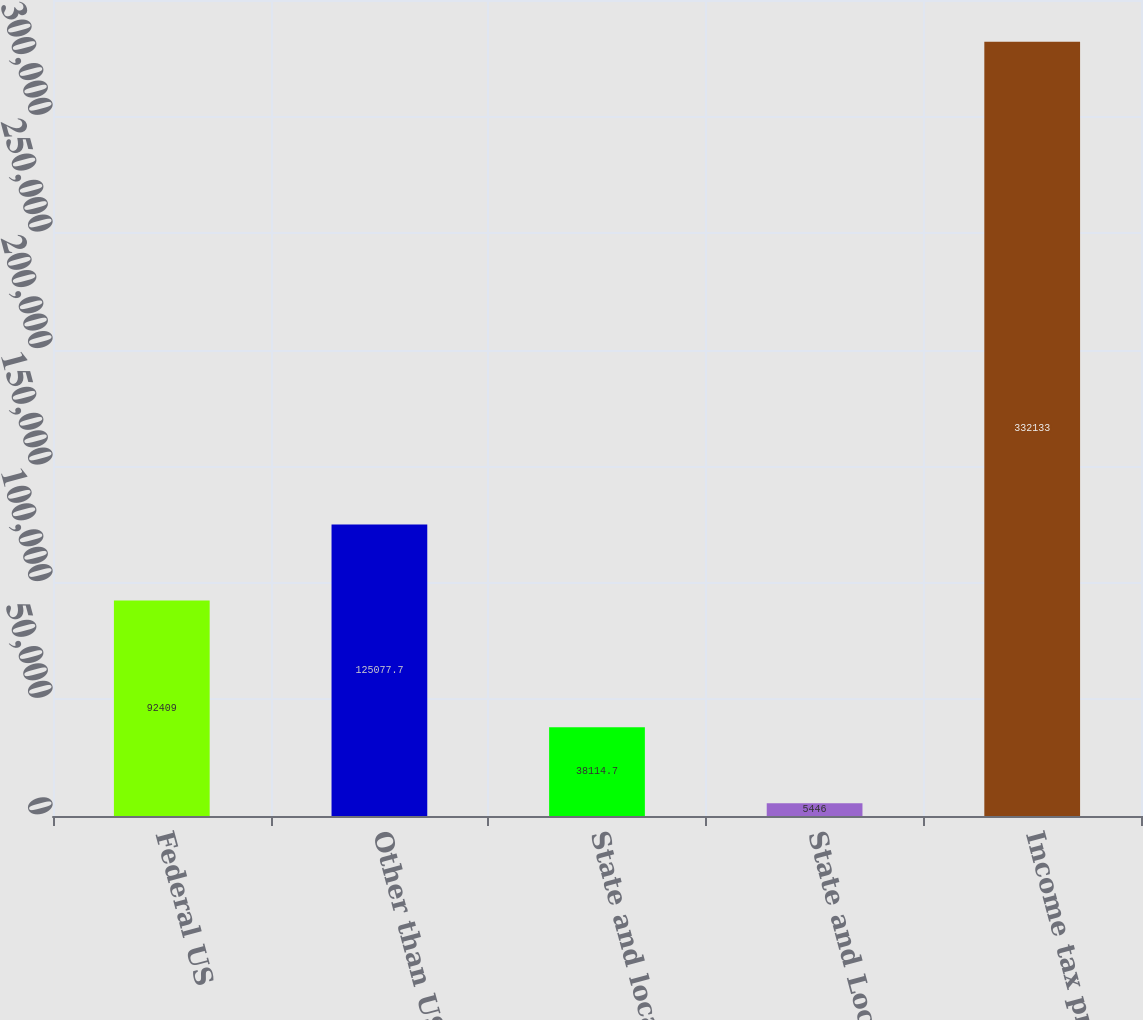Convert chart to OTSL. <chart><loc_0><loc_0><loc_500><loc_500><bar_chart><fcel>Federal US<fcel>Other than US<fcel>State and local<fcel>State and Local<fcel>Income tax provision<nl><fcel>92409<fcel>125078<fcel>38114.7<fcel>5446<fcel>332133<nl></chart> 